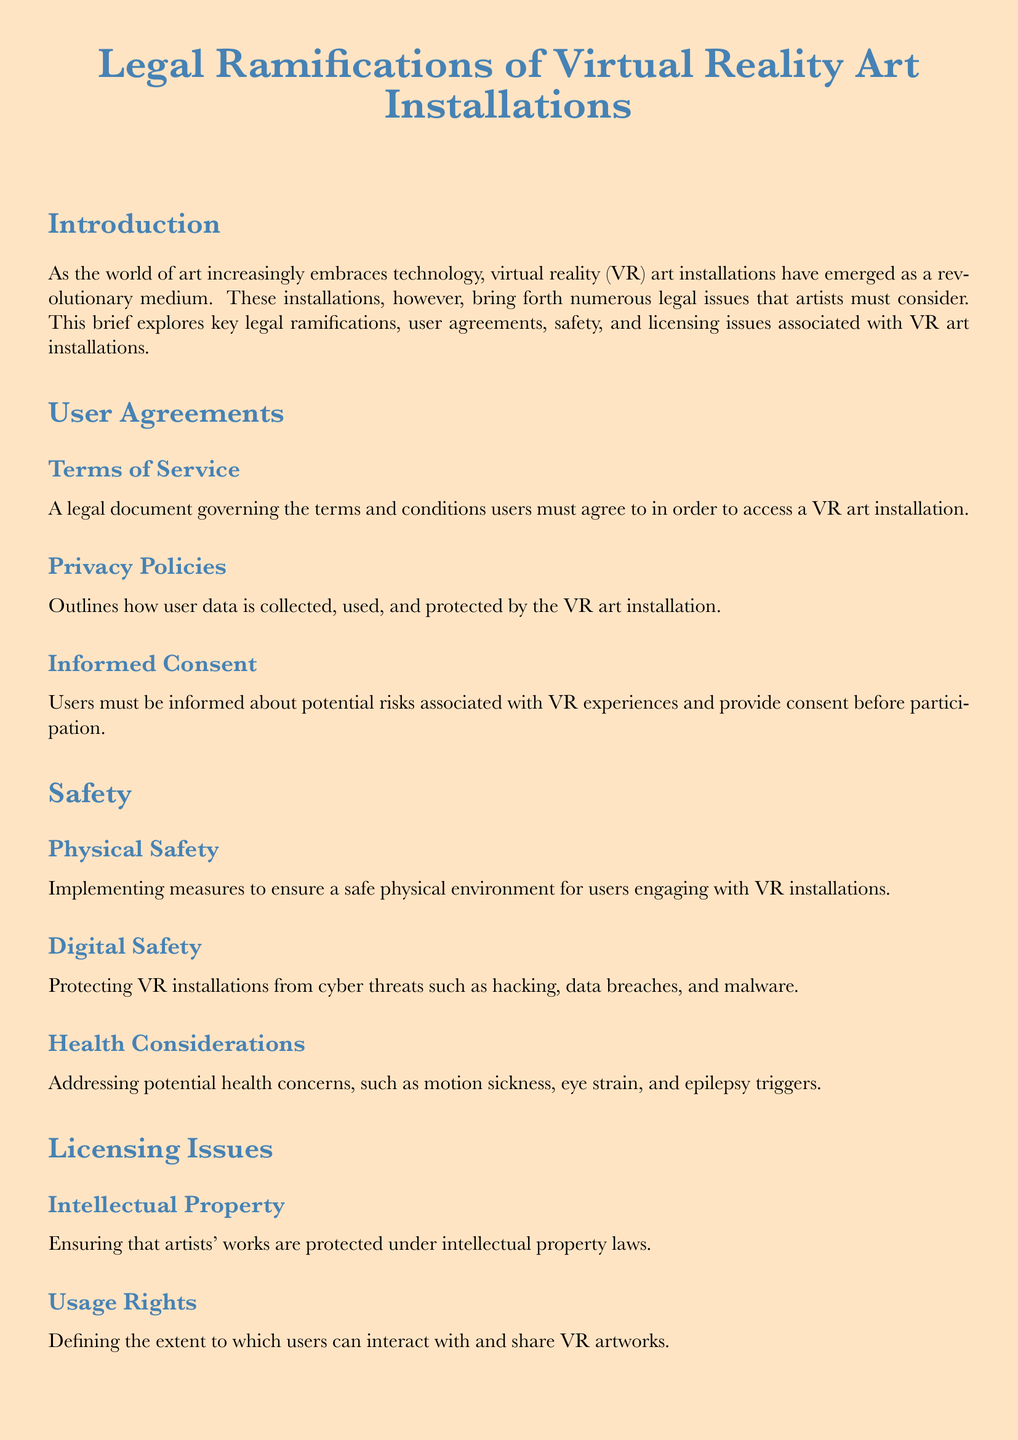What is the primary medium discussed in the document? The document focuses on virtual reality art installations as a burgeoning medium in the art world.
Answer: virtual reality art installations What must users provide to participate in VR experiences? Users are required to provide informed consent regarding potential risks associated with VR experiences.
Answer: consent What are the two main types of safety concerns mentioned? The document highlights physical safety and digital safety as key concerns for users in VR installations.
Answer: physical safety and digital safety Which legal aspect ensures protection of artists' works? Intellectual property laws are referenced as the means to protect artists' works in VR installations.
Answer: intellectual property What is a key component of user agreements for VR art installations? Terms of service outline the terms and conditions that users must accept to access the installations.
Answer: terms of service What health issue is addressed in the safety section? The document mentions potential health concerns, including motion sickness, eye strain, and epilepsy triggers.
Answer: motion sickness Which type of content must be properly licensed according to the document? The document emphasizes that all third-party content used in VR installations must be properly licensed.
Answer: third-party content What is required for user data in VR installations? Privacy policies must outline how user data is collected, used, and protected in VR art installations.
Answer: privacy policies What is the concluding emphasis of the document? The conclusion stresses the importance of addressing legal complexities around user agreements, safety, and licensing.
Answer: legal complexities 